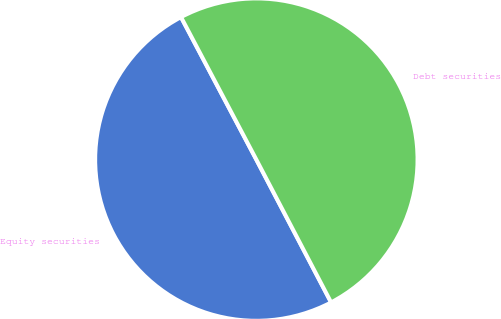Convert chart. <chart><loc_0><loc_0><loc_500><loc_500><pie_chart><fcel>Equity securities<fcel>Debt securities<nl><fcel>49.94%<fcel>50.06%<nl></chart> 